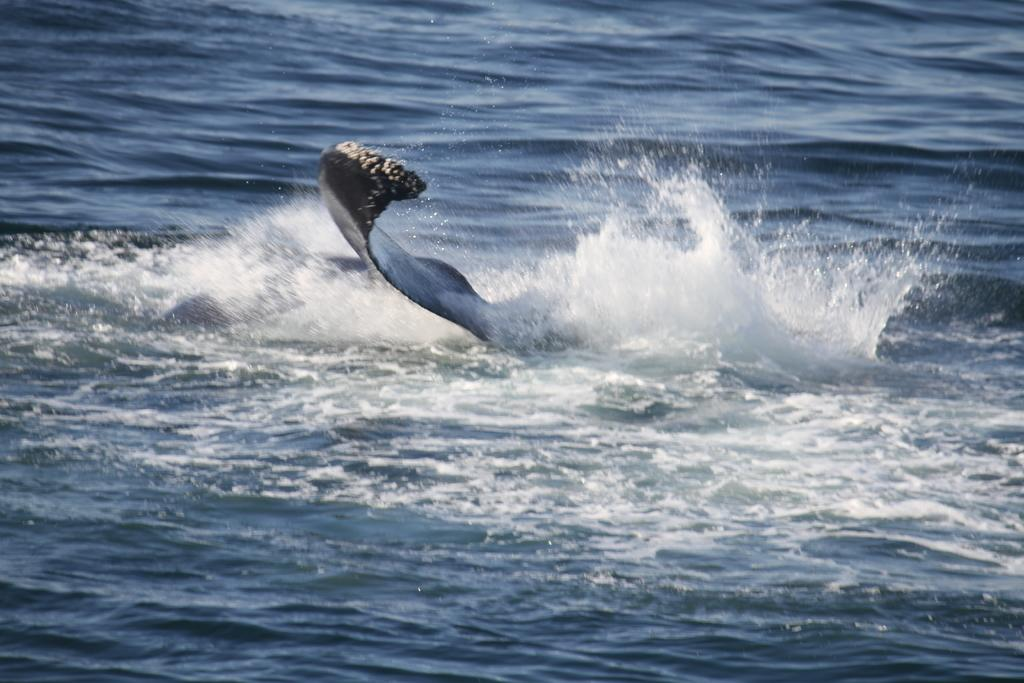What type of animal is present in the image? There is an aquatic animal in the image. Can you describe the environment in which the aquatic animal is situated? The aquatic animal is in the water. What is the name of the aquatic animal in the image? The provided facts do not mention the name of the aquatic animal, so it cannot be determined from the image. What type of jam is being used by the aquatic animal in the image? There is no jam present in the image, as it features an aquatic animal in the water. 